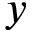Convert formula to latex. <formula><loc_0><loc_0><loc_500><loc_500>y</formula> 